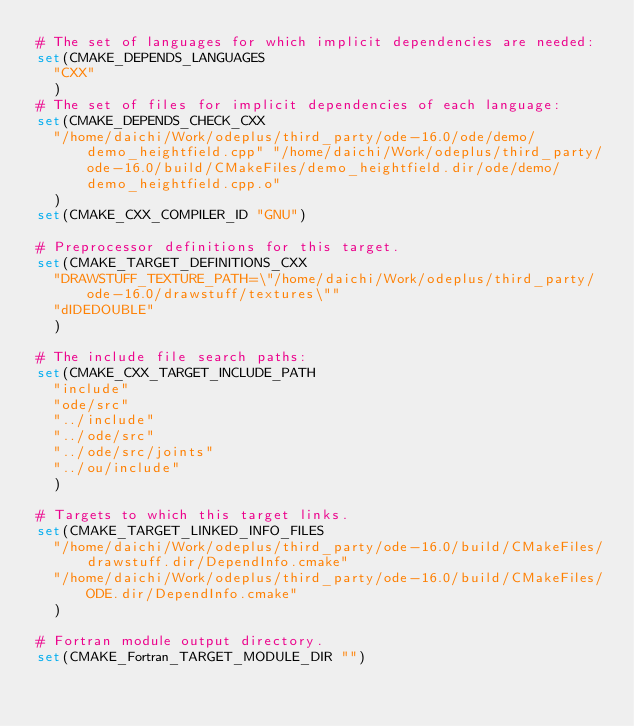Convert code to text. <code><loc_0><loc_0><loc_500><loc_500><_CMake_># The set of languages for which implicit dependencies are needed:
set(CMAKE_DEPENDS_LANGUAGES
  "CXX"
  )
# The set of files for implicit dependencies of each language:
set(CMAKE_DEPENDS_CHECK_CXX
  "/home/daichi/Work/odeplus/third_party/ode-16.0/ode/demo/demo_heightfield.cpp" "/home/daichi/Work/odeplus/third_party/ode-16.0/build/CMakeFiles/demo_heightfield.dir/ode/demo/demo_heightfield.cpp.o"
  )
set(CMAKE_CXX_COMPILER_ID "GNU")

# Preprocessor definitions for this target.
set(CMAKE_TARGET_DEFINITIONS_CXX
  "DRAWSTUFF_TEXTURE_PATH=\"/home/daichi/Work/odeplus/third_party/ode-16.0/drawstuff/textures\""
  "dIDEDOUBLE"
  )

# The include file search paths:
set(CMAKE_CXX_TARGET_INCLUDE_PATH
  "include"
  "ode/src"
  "../include"
  "../ode/src"
  "../ode/src/joints"
  "../ou/include"
  )

# Targets to which this target links.
set(CMAKE_TARGET_LINKED_INFO_FILES
  "/home/daichi/Work/odeplus/third_party/ode-16.0/build/CMakeFiles/drawstuff.dir/DependInfo.cmake"
  "/home/daichi/Work/odeplus/third_party/ode-16.0/build/CMakeFiles/ODE.dir/DependInfo.cmake"
  )

# Fortran module output directory.
set(CMAKE_Fortran_TARGET_MODULE_DIR "")
</code> 